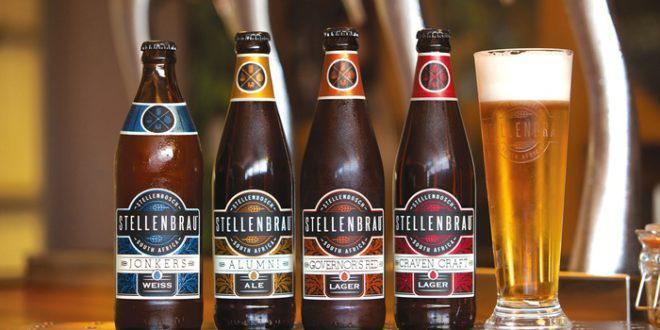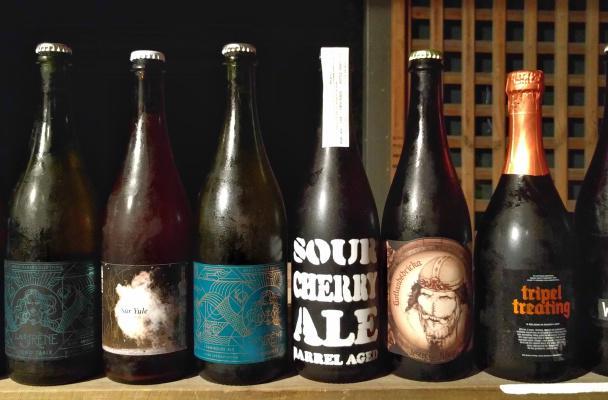The first image is the image on the left, the second image is the image on the right. For the images shown, is this caption "A tall glass of beer is shown in only one image." true? Answer yes or no. Yes. 